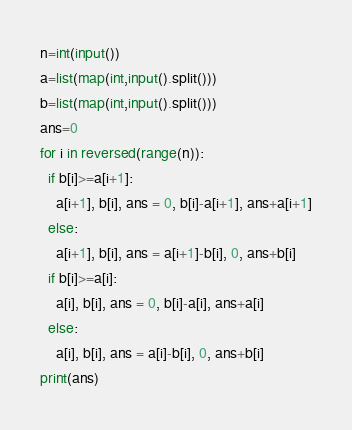Convert code to text. <code><loc_0><loc_0><loc_500><loc_500><_Python_>n=int(input())
a=list(map(int,input().split()))
b=list(map(int,input().split()))
ans=0
for i in reversed(range(n)):
  if b[i]>=a[i+1]:
    a[i+1], b[i], ans = 0, b[i]-a[i+1], ans+a[i+1]
  else:
    a[i+1], b[i], ans = a[i+1]-b[i], 0, ans+b[i]
  if b[i]>=a[i]:
    a[i], b[i], ans = 0, b[i]-a[i], ans+a[i]
  else:
    a[i], b[i], ans = a[i]-b[i], 0, ans+b[i]
print(ans)</code> 